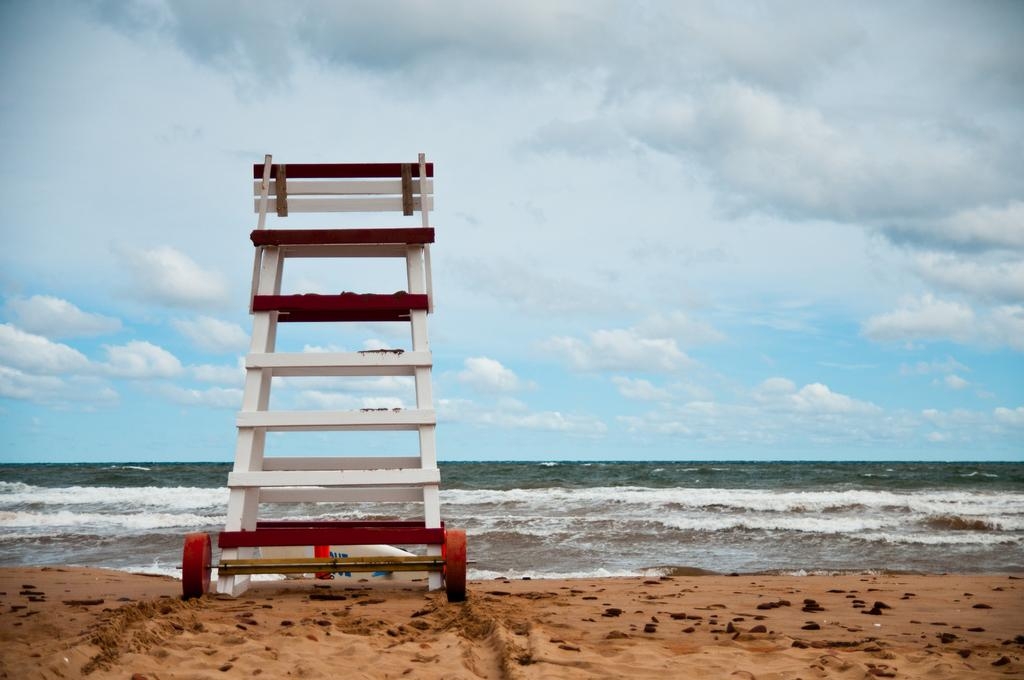What type of ladder is in the image? There is a white color ladder with wheels in the image. Where is the ladder located? The ladder is located on the beach. What type of terrain is visible in the image? There is sand visible in the image. What can be seen in the background of the image? There is an ocean and the sky visible in the background of the image. What is the condition of the sky in the image? The sky has clouds in it. Can you see a ghost interacting with the ladder in the image? There is no ghost present in the image, and therefore no such interaction can be observed. What type of frame is used to hold the ladder in the image? The ladder does not require a frame to hold it in the image, as it has wheels for mobility. 